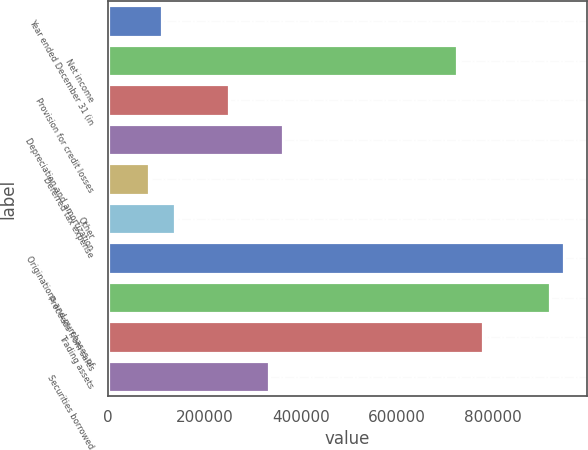<chart> <loc_0><loc_0><loc_500><loc_500><bar_chart><fcel>Year ended December 31 (in<fcel>Net income<fcel>Provision for credit losses<fcel>Depreciation and amortization<fcel>Deferred tax expense<fcel>Other<fcel>Originations and purchases of<fcel>Proceeds from sales<fcel>Trading assets<fcel>Securities borrowed<nl><fcel>111694<fcel>724390<fcel>250943<fcel>362342<fcel>83844.4<fcel>139544<fcel>947188<fcel>919338<fcel>780089<fcel>334493<nl></chart> 